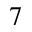<formula> <loc_0><loc_0><loc_500><loc_500>_ { 7 }</formula> 